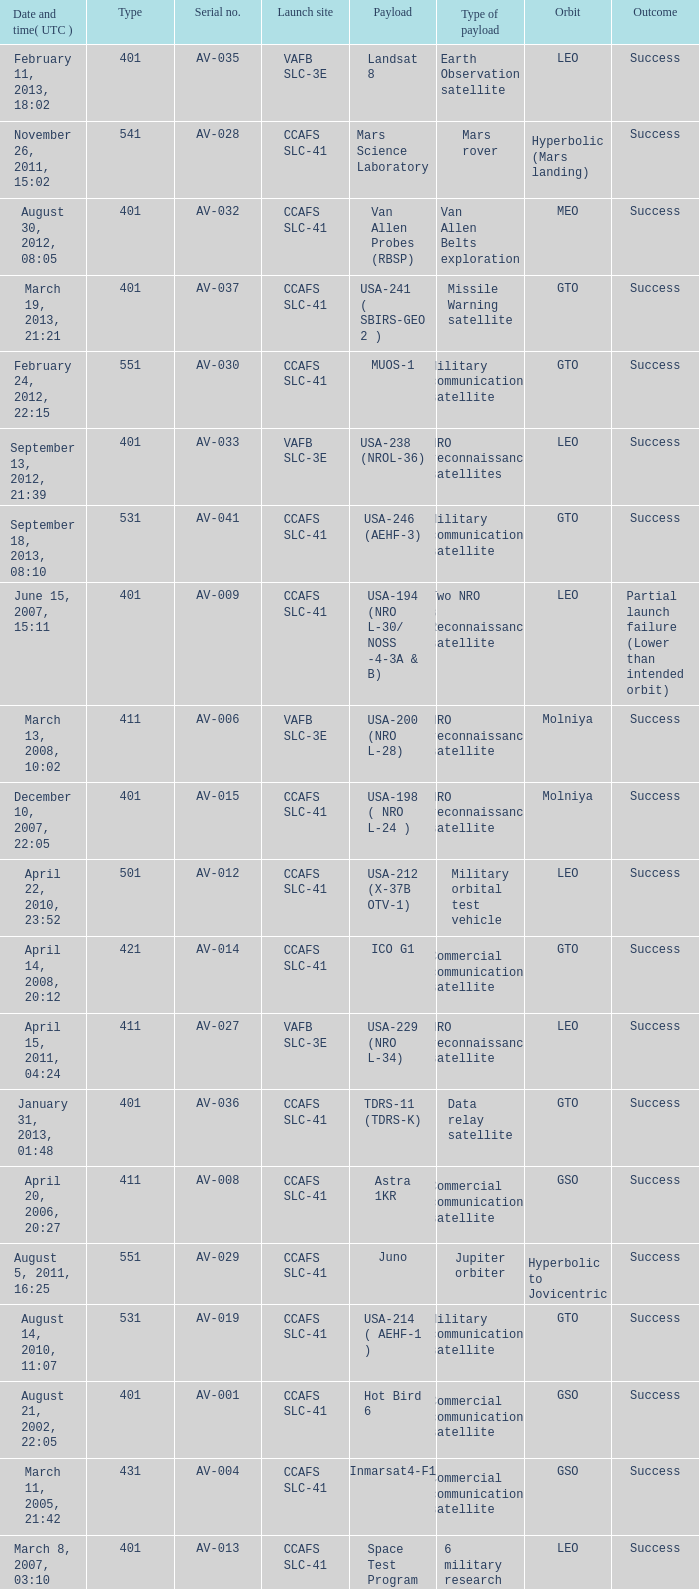When was the payload of Commercial Communications Satellite amc16? December 17, 2004, 12:07. 